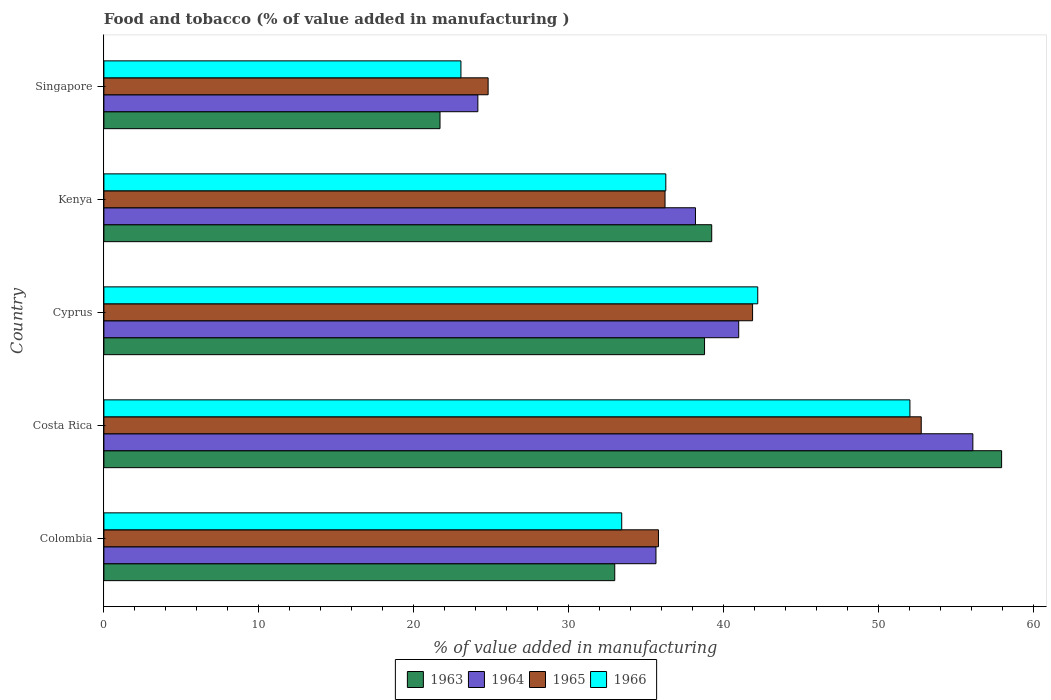How many different coloured bars are there?
Keep it short and to the point. 4. How many groups of bars are there?
Your answer should be compact. 5. How many bars are there on the 2nd tick from the top?
Provide a succinct answer. 4. How many bars are there on the 3rd tick from the bottom?
Give a very brief answer. 4. In how many cases, is the number of bars for a given country not equal to the number of legend labels?
Your answer should be compact. 0. What is the value added in manufacturing food and tobacco in 1965 in Colombia?
Your answer should be compact. 35.78. Across all countries, what is the maximum value added in manufacturing food and tobacco in 1964?
Your answer should be very brief. 56.07. Across all countries, what is the minimum value added in manufacturing food and tobacco in 1965?
Your answer should be compact. 24.79. In which country was the value added in manufacturing food and tobacco in 1965 minimum?
Give a very brief answer. Singapore. What is the total value added in manufacturing food and tobacco in 1964 in the graph?
Make the answer very short. 194.94. What is the difference between the value added in manufacturing food and tobacco in 1966 in Costa Rica and that in Singapore?
Offer a very short reply. 28.97. What is the difference between the value added in manufacturing food and tobacco in 1966 in Cyprus and the value added in manufacturing food and tobacco in 1965 in Kenya?
Provide a short and direct response. 5.98. What is the average value added in manufacturing food and tobacco in 1965 per country?
Ensure brevity in your answer.  38.27. What is the difference between the value added in manufacturing food and tobacco in 1963 and value added in manufacturing food and tobacco in 1965 in Cyprus?
Your response must be concise. -3.1. In how many countries, is the value added in manufacturing food and tobacco in 1964 greater than 50 %?
Provide a short and direct response. 1. What is the ratio of the value added in manufacturing food and tobacco in 1963 in Kenya to that in Singapore?
Provide a short and direct response. 1.81. Is the difference between the value added in manufacturing food and tobacco in 1963 in Kenya and Singapore greater than the difference between the value added in manufacturing food and tobacco in 1965 in Kenya and Singapore?
Make the answer very short. Yes. What is the difference between the highest and the second highest value added in manufacturing food and tobacco in 1964?
Offer a very short reply. 15.11. What is the difference between the highest and the lowest value added in manufacturing food and tobacco in 1964?
Keep it short and to the point. 31.94. Is the sum of the value added in manufacturing food and tobacco in 1963 in Cyprus and Kenya greater than the maximum value added in manufacturing food and tobacco in 1966 across all countries?
Your answer should be compact. Yes. What does the 1st bar from the top in Kenya represents?
Offer a terse response. 1966. What does the 2nd bar from the bottom in Colombia represents?
Offer a terse response. 1964. How many bars are there?
Give a very brief answer. 20. How many countries are there in the graph?
Ensure brevity in your answer.  5. What is the difference between two consecutive major ticks on the X-axis?
Ensure brevity in your answer.  10. Does the graph contain any zero values?
Your answer should be compact. No. Does the graph contain grids?
Your answer should be very brief. No. Where does the legend appear in the graph?
Your answer should be very brief. Bottom center. What is the title of the graph?
Ensure brevity in your answer.  Food and tobacco (% of value added in manufacturing ). What is the label or title of the X-axis?
Give a very brief answer. % of value added in manufacturing. What is the label or title of the Y-axis?
Offer a very short reply. Country. What is the % of value added in manufacturing in 1963 in Colombia?
Offer a terse response. 32.96. What is the % of value added in manufacturing in 1964 in Colombia?
Offer a very short reply. 35.62. What is the % of value added in manufacturing in 1965 in Colombia?
Your answer should be very brief. 35.78. What is the % of value added in manufacturing of 1966 in Colombia?
Your answer should be very brief. 33.41. What is the % of value added in manufacturing in 1963 in Costa Rica?
Offer a terse response. 57.92. What is the % of value added in manufacturing in 1964 in Costa Rica?
Offer a terse response. 56.07. What is the % of value added in manufacturing of 1965 in Costa Rica?
Your response must be concise. 52.73. What is the % of value added in manufacturing of 1966 in Costa Rica?
Provide a short and direct response. 52. What is the % of value added in manufacturing in 1963 in Cyprus?
Make the answer very short. 38.75. What is the % of value added in manufacturing in 1964 in Cyprus?
Make the answer very short. 40.96. What is the % of value added in manufacturing in 1965 in Cyprus?
Offer a very short reply. 41.85. What is the % of value added in manufacturing of 1966 in Cyprus?
Provide a succinct answer. 42.19. What is the % of value added in manufacturing in 1963 in Kenya?
Keep it short and to the point. 39.22. What is the % of value added in manufacturing of 1964 in Kenya?
Give a very brief answer. 38.17. What is the % of value added in manufacturing in 1965 in Kenya?
Offer a very short reply. 36.2. What is the % of value added in manufacturing in 1966 in Kenya?
Make the answer very short. 36.25. What is the % of value added in manufacturing in 1963 in Singapore?
Make the answer very short. 21.69. What is the % of value added in manufacturing in 1964 in Singapore?
Make the answer very short. 24.13. What is the % of value added in manufacturing of 1965 in Singapore?
Ensure brevity in your answer.  24.79. What is the % of value added in manufacturing in 1966 in Singapore?
Offer a very short reply. 23.04. Across all countries, what is the maximum % of value added in manufacturing in 1963?
Your answer should be compact. 57.92. Across all countries, what is the maximum % of value added in manufacturing in 1964?
Give a very brief answer. 56.07. Across all countries, what is the maximum % of value added in manufacturing of 1965?
Your answer should be very brief. 52.73. Across all countries, what is the maximum % of value added in manufacturing of 1966?
Your answer should be compact. 52. Across all countries, what is the minimum % of value added in manufacturing of 1963?
Offer a terse response. 21.69. Across all countries, what is the minimum % of value added in manufacturing of 1964?
Your answer should be very brief. 24.13. Across all countries, what is the minimum % of value added in manufacturing in 1965?
Provide a succinct answer. 24.79. Across all countries, what is the minimum % of value added in manufacturing of 1966?
Offer a terse response. 23.04. What is the total % of value added in manufacturing in 1963 in the graph?
Provide a succinct answer. 190.54. What is the total % of value added in manufacturing in 1964 in the graph?
Give a very brief answer. 194.94. What is the total % of value added in manufacturing in 1965 in the graph?
Make the answer very short. 191.36. What is the total % of value added in manufacturing of 1966 in the graph?
Offer a terse response. 186.89. What is the difference between the % of value added in manufacturing in 1963 in Colombia and that in Costa Rica?
Your answer should be very brief. -24.96. What is the difference between the % of value added in manufacturing of 1964 in Colombia and that in Costa Rica?
Your answer should be very brief. -20.45. What is the difference between the % of value added in manufacturing in 1965 in Colombia and that in Costa Rica?
Your answer should be very brief. -16.95. What is the difference between the % of value added in manufacturing of 1966 in Colombia and that in Costa Rica?
Give a very brief answer. -18.59. What is the difference between the % of value added in manufacturing in 1963 in Colombia and that in Cyprus?
Offer a very short reply. -5.79. What is the difference between the % of value added in manufacturing in 1964 in Colombia and that in Cyprus?
Give a very brief answer. -5.34. What is the difference between the % of value added in manufacturing in 1965 in Colombia and that in Cyprus?
Offer a terse response. -6.07. What is the difference between the % of value added in manufacturing of 1966 in Colombia and that in Cyprus?
Your answer should be very brief. -8.78. What is the difference between the % of value added in manufacturing in 1963 in Colombia and that in Kenya?
Ensure brevity in your answer.  -6.26. What is the difference between the % of value added in manufacturing of 1964 in Colombia and that in Kenya?
Your response must be concise. -2.55. What is the difference between the % of value added in manufacturing in 1965 in Colombia and that in Kenya?
Offer a terse response. -0.42. What is the difference between the % of value added in manufacturing in 1966 in Colombia and that in Kenya?
Your answer should be very brief. -2.84. What is the difference between the % of value added in manufacturing of 1963 in Colombia and that in Singapore?
Ensure brevity in your answer.  11.27. What is the difference between the % of value added in manufacturing in 1964 in Colombia and that in Singapore?
Give a very brief answer. 11.49. What is the difference between the % of value added in manufacturing in 1965 in Colombia and that in Singapore?
Provide a succinct answer. 10.99. What is the difference between the % of value added in manufacturing in 1966 in Colombia and that in Singapore?
Make the answer very short. 10.37. What is the difference between the % of value added in manufacturing of 1963 in Costa Rica and that in Cyprus?
Your response must be concise. 19.17. What is the difference between the % of value added in manufacturing in 1964 in Costa Rica and that in Cyprus?
Your answer should be very brief. 15.11. What is the difference between the % of value added in manufacturing in 1965 in Costa Rica and that in Cyprus?
Ensure brevity in your answer.  10.88. What is the difference between the % of value added in manufacturing of 1966 in Costa Rica and that in Cyprus?
Offer a terse response. 9.82. What is the difference between the % of value added in manufacturing of 1963 in Costa Rica and that in Kenya?
Ensure brevity in your answer.  18.7. What is the difference between the % of value added in manufacturing in 1964 in Costa Rica and that in Kenya?
Keep it short and to the point. 17.9. What is the difference between the % of value added in manufacturing of 1965 in Costa Rica and that in Kenya?
Your response must be concise. 16.53. What is the difference between the % of value added in manufacturing in 1966 in Costa Rica and that in Kenya?
Provide a succinct answer. 15.75. What is the difference between the % of value added in manufacturing of 1963 in Costa Rica and that in Singapore?
Provide a short and direct response. 36.23. What is the difference between the % of value added in manufacturing of 1964 in Costa Rica and that in Singapore?
Ensure brevity in your answer.  31.94. What is the difference between the % of value added in manufacturing in 1965 in Costa Rica and that in Singapore?
Keep it short and to the point. 27.94. What is the difference between the % of value added in manufacturing in 1966 in Costa Rica and that in Singapore?
Your answer should be compact. 28.97. What is the difference between the % of value added in manufacturing in 1963 in Cyprus and that in Kenya?
Offer a terse response. -0.46. What is the difference between the % of value added in manufacturing of 1964 in Cyprus and that in Kenya?
Keep it short and to the point. 2.79. What is the difference between the % of value added in manufacturing of 1965 in Cyprus and that in Kenya?
Ensure brevity in your answer.  5.65. What is the difference between the % of value added in manufacturing in 1966 in Cyprus and that in Kenya?
Your response must be concise. 5.93. What is the difference between the % of value added in manufacturing in 1963 in Cyprus and that in Singapore?
Give a very brief answer. 17.07. What is the difference between the % of value added in manufacturing in 1964 in Cyprus and that in Singapore?
Give a very brief answer. 16.83. What is the difference between the % of value added in manufacturing of 1965 in Cyprus and that in Singapore?
Make the answer very short. 17.06. What is the difference between the % of value added in manufacturing of 1966 in Cyprus and that in Singapore?
Keep it short and to the point. 19.15. What is the difference between the % of value added in manufacturing in 1963 in Kenya and that in Singapore?
Provide a succinct answer. 17.53. What is the difference between the % of value added in manufacturing in 1964 in Kenya and that in Singapore?
Your answer should be very brief. 14.04. What is the difference between the % of value added in manufacturing of 1965 in Kenya and that in Singapore?
Give a very brief answer. 11.41. What is the difference between the % of value added in manufacturing in 1966 in Kenya and that in Singapore?
Make the answer very short. 13.22. What is the difference between the % of value added in manufacturing of 1963 in Colombia and the % of value added in manufacturing of 1964 in Costa Rica?
Give a very brief answer. -23.11. What is the difference between the % of value added in manufacturing of 1963 in Colombia and the % of value added in manufacturing of 1965 in Costa Rica?
Give a very brief answer. -19.77. What is the difference between the % of value added in manufacturing in 1963 in Colombia and the % of value added in manufacturing in 1966 in Costa Rica?
Offer a very short reply. -19.04. What is the difference between the % of value added in manufacturing in 1964 in Colombia and the % of value added in manufacturing in 1965 in Costa Rica?
Provide a succinct answer. -17.11. What is the difference between the % of value added in manufacturing of 1964 in Colombia and the % of value added in manufacturing of 1966 in Costa Rica?
Your answer should be compact. -16.38. What is the difference between the % of value added in manufacturing in 1965 in Colombia and the % of value added in manufacturing in 1966 in Costa Rica?
Provide a short and direct response. -16.22. What is the difference between the % of value added in manufacturing in 1963 in Colombia and the % of value added in manufacturing in 1964 in Cyprus?
Offer a terse response. -8. What is the difference between the % of value added in manufacturing of 1963 in Colombia and the % of value added in manufacturing of 1965 in Cyprus?
Provide a short and direct response. -8.89. What is the difference between the % of value added in manufacturing of 1963 in Colombia and the % of value added in manufacturing of 1966 in Cyprus?
Provide a short and direct response. -9.23. What is the difference between the % of value added in manufacturing in 1964 in Colombia and the % of value added in manufacturing in 1965 in Cyprus?
Keep it short and to the point. -6.23. What is the difference between the % of value added in manufacturing of 1964 in Colombia and the % of value added in manufacturing of 1966 in Cyprus?
Provide a short and direct response. -6.57. What is the difference between the % of value added in manufacturing in 1965 in Colombia and the % of value added in manufacturing in 1966 in Cyprus?
Offer a terse response. -6.41. What is the difference between the % of value added in manufacturing of 1963 in Colombia and the % of value added in manufacturing of 1964 in Kenya?
Give a very brief answer. -5.21. What is the difference between the % of value added in manufacturing of 1963 in Colombia and the % of value added in manufacturing of 1965 in Kenya?
Offer a terse response. -3.24. What is the difference between the % of value added in manufacturing of 1963 in Colombia and the % of value added in manufacturing of 1966 in Kenya?
Your answer should be compact. -3.29. What is the difference between the % of value added in manufacturing in 1964 in Colombia and the % of value added in manufacturing in 1965 in Kenya?
Provide a short and direct response. -0.58. What is the difference between the % of value added in manufacturing in 1964 in Colombia and the % of value added in manufacturing in 1966 in Kenya?
Keep it short and to the point. -0.63. What is the difference between the % of value added in manufacturing in 1965 in Colombia and the % of value added in manufacturing in 1966 in Kenya?
Your response must be concise. -0.47. What is the difference between the % of value added in manufacturing of 1963 in Colombia and the % of value added in manufacturing of 1964 in Singapore?
Your answer should be very brief. 8.83. What is the difference between the % of value added in manufacturing of 1963 in Colombia and the % of value added in manufacturing of 1965 in Singapore?
Offer a very short reply. 8.17. What is the difference between the % of value added in manufacturing of 1963 in Colombia and the % of value added in manufacturing of 1966 in Singapore?
Offer a very short reply. 9.92. What is the difference between the % of value added in manufacturing of 1964 in Colombia and the % of value added in manufacturing of 1965 in Singapore?
Provide a short and direct response. 10.83. What is the difference between the % of value added in manufacturing of 1964 in Colombia and the % of value added in manufacturing of 1966 in Singapore?
Offer a terse response. 12.58. What is the difference between the % of value added in manufacturing in 1965 in Colombia and the % of value added in manufacturing in 1966 in Singapore?
Your answer should be compact. 12.74. What is the difference between the % of value added in manufacturing of 1963 in Costa Rica and the % of value added in manufacturing of 1964 in Cyprus?
Give a very brief answer. 16.96. What is the difference between the % of value added in manufacturing in 1963 in Costa Rica and the % of value added in manufacturing in 1965 in Cyprus?
Make the answer very short. 16.07. What is the difference between the % of value added in manufacturing in 1963 in Costa Rica and the % of value added in manufacturing in 1966 in Cyprus?
Make the answer very short. 15.73. What is the difference between the % of value added in manufacturing in 1964 in Costa Rica and the % of value added in manufacturing in 1965 in Cyprus?
Your answer should be compact. 14.21. What is the difference between the % of value added in manufacturing of 1964 in Costa Rica and the % of value added in manufacturing of 1966 in Cyprus?
Give a very brief answer. 13.88. What is the difference between the % of value added in manufacturing of 1965 in Costa Rica and the % of value added in manufacturing of 1966 in Cyprus?
Make the answer very short. 10.55. What is the difference between the % of value added in manufacturing of 1963 in Costa Rica and the % of value added in manufacturing of 1964 in Kenya?
Your response must be concise. 19.75. What is the difference between the % of value added in manufacturing in 1963 in Costa Rica and the % of value added in manufacturing in 1965 in Kenya?
Offer a terse response. 21.72. What is the difference between the % of value added in manufacturing of 1963 in Costa Rica and the % of value added in manufacturing of 1966 in Kenya?
Provide a short and direct response. 21.67. What is the difference between the % of value added in manufacturing of 1964 in Costa Rica and the % of value added in manufacturing of 1965 in Kenya?
Offer a terse response. 19.86. What is the difference between the % of value added in manufacturing in 1964 in Costa Rica and the % of value added in manufacturing in 1966 in Kenya?
Ensure brevity in your answer.  19.81. What is the difference between the % of value added in manufacturing of 1965 in Costa Rica and the % of value added in manufacturing of 1966 in Kenya?
Provide a succinct answer. 16.48. What is the difference between the % of value added in manufacturing in 1963 in Costa Rica and the % of value added in manufacturing in 1964 in Singapore?
Your answer should be very brief. 33.79. What is the difference between the % of value added in manufacturing of 1963 in Costa Rica and the % of value added in manufacturing of 1965 in Singapore?
Ensure brevity in your answer.  33.13. What is the difference between the % of value added in manufacturing in 1963 in Costa Rica and the % of value added in manufacturing in 1966 in Singapore?
Give a very brief answer. 34.88. What is the difference between the % of value added in manufacturing of 1964 in Costa Rica and the % of value added in manufacturing of 1965 in Singapore?
Keep it short and to the point. 31.28. What is the difference between the % of value added in manufacturing in 1964 in Costa Rica and the % of value added in manufacturing in 1966 in Singapore?
Your answer should be compact. 33.03. What is the difference between the % of value added in manufacturing in 1965 in Costa Rica and the % of value added in manufacturing in 1966 in Singapore?
Provide a short and direct response. 29.7. What is the difference between the % of value added in manufacturing in 1963 in Cyprus and the % of value added in manufacturing in 1964 in Kenya?
Your answer should be compact. 0.59. What is the difference between the % of value added in manufacturing in 1963 in Cyprus and the % of value added in manufacturing in 1965 in Kenya?
Give a very brief answer. 2.55. What is the difference between the % of value added in manufacturing in 1963 in Cyprus and the % of value added in manufacturing in 1966 in Kenya?
Make the answer very short. 2.5. What is the difference between the % of value added in manufacturing of 1964 in Cyprus and the % of value added in manufacturing of 1965 in Kenya?
Keep it short and to the point. 4.75. What is the difference between the % of value added in manufacturing in 1964 in Cyprus and the % of value added in manufacturing in 1966 in Kenya?
Offer a very short reply. 4.7. What is the difference between the % of value added in manufacturing in 1965 in Cyprus and the % of value added in manufacturing in 1966 in Kenya?
Offer a very short reply. 5.6. What is the difference between the % of value added in manufacturing in 1963 in Cyprus and the % of value added in manufacturing in 1964 in Singapore?
Provide a short and direct response. 14.63. What is the difference between the % of value added in manufacturing in 1963 in Cyprus and the % of value added in manufacturing in 1965 in Singapore?
Offer a very short reply. 13.96. What is the difference between the % of value added in manufacturing in 1963 in Cyprus and the % of value added in manufacturing in 1966 in Singapore?
Your response must be concise. 15.72. What is the difference between the % of value added in manufacturing of 1964 in Cyprus and the % of value added in manufacturing of 1965 in Singapore?
Give a very brief answer. 16.17. What is the difference between the % of value added in manufacturing of 1964 in Cyprus and the % of value added in manufacturing of 1966 in Singapore?
Offer a terse response. 17.92. What is the difference between the % of value added in manufacturing in 1965 in Cyprus and the % of value added in manufacturing in 1966 in Singapore?
Make the answer very short. 18.82. What is the difference between the % of value added in manufacturing of 1963 in Kenya and the % of value added in manufacturing of 1964 in Singapore?
Keep it short and to the point. 15.09. What is the difference between the % of value added in manufacturing in 1963 in Kenya and the % of value added in manufacturing in 1965 in Singapore?
Give a very brief answer. 14.43. What is the difference between the % of value added in manufacturing of 1963 in Kenya and the % of value added in manufacturing of 1966 in Singapore?
Offer a very short reply. 16.18. What is the difference between the % of value added in manufacturing in 1964 in Kenya and the % of value added in manufacturing in 1965 in Singapore?
Your response must be concise. 13.38. What is the difference between the % of value added in manufacturing of 1964 in Kenya and the % of value added in manufacturing of 1966 in Singapore?
Offer a terse response. 15.13. What is the difference between the % of value added in manufacturing of 1965 in Kenya and the % of value added in manufacturing of 1966 in Singapore?
Make the answer very short. 13.17. What is the average % of value added in manufacturing in 1963 per country?
Provide a short and direct response. 38.11. What is the average % of value added in manufacturing in 1964 per country?
Your answer should be very brief. 38.99. What is the average % of value added in manufacturing in 1965 per country?
Offer a terse response. 38.27. What is the average % of value added in manufacturing in 1966 per country?
Offer a terse response. 37.38. What is the difference between the % of value added in manufacturing in 1963 and % of value added in manufacturing in 1964 in Colombia?
Ensure brevity in your answer.  -2.66. What is the difference between the % of value added in manufacturing in 1963 and % of value added in manufacturing in 1965 in Colombia?
Ensure brevity in your answer.  -2.82. What is the difference between the % of value added in manufacturing of 1963 and % of value added in manufacturing of 1966 in Colombia?
Provide a short and direct response. -0.45. What is the difference between the % of value added in manufacturing in 1964 and % of value added in manufacturing in 1965 in Colombia?
Keep it short and to the point. -0.16. What is the difference between the % of value added in manufacturing of 1964 and % of value added in manufacturing of 1966 in Colombia?
Offer a very short reply. 2.21. What is the difference between the % of value added in manufacturing in 1965 and % of value added in manufacturing in 1966 in Colombia?
Offer a terse response. 2.37. What is the difference between the % of value added in manufacturing of 1963 and % of value added in manufacturing of 1964 in Costa Rica?
Make the answer very short. 1.85. What is the difference between the % of value added in manufacturing of 1963 and % of value added in manufacturing of 1965 in Costa Rica?
Provide a succinct answer. 5.19. What is the difference between the % of value added in manufacturing of 1963 and % of value added in manufacturing of 1966 in Costa Rica?
Your answer should be very brief. 5.92. What is the difference between the % of value added in manufacturing of 1964 and % of value added in manufacturing of 1965 in Costa Rica?
Make the answer very short. 3.33. What is the difference between the % of value added in manufacturing in 1964 and % of value added in manufacturing in 1966 in Costa Rica?
Offer a terse response. 4.06. What is the difference between the % of value added in manufacturing in 1965 and % of value added in manufacturing in 1966 in Costa Rica?
Offer a very short reply. 0.73. What is the difference between the % of value added in manufacturing of 1963 and % of value added in manufacturing of 1964 in Cyprus?
Provide a short and direct response. -2.2. What is the difference between the % of value added in manufacturing in 1963 and % of value added in manufacturing in 1965 in Cyprus?
Your answer should be compact. -3.1. What is the difference between the % of value added in manufacturing of 1963 and % of value added in manufacturing of 1966 in Cyprus?
Provide a short and direct response. -3.43. What is the difference between the % of value added in manufacturing of 1964 and % of value added in manufacturing of 1965 in Cyprus?
Your response must be concise. -0.9. What is the difference between the % of value added in manufacturing in 1964 and % of value added in manufacturing in 1966 in Cyprus?
Give a very brief answer. -1.23. What is the difference between the % of value added in manufacturing in 1963 and % of value added in manufacturing in 1964 in Kenya?
Your answer should be very brief. 1.05. What is the difference between the % of value added in manufacturing in 1963 and % of value added in manufacturing in 1965 in Kenya?
Your answer should be very brief. 3.01. What is the difference between the % of value added in manufacturing in 1963 and % of value added in manufacturing in 1966 in Kenya?
Your answer should be compact. 2.96. What is the difference between the % of value added in manufacturing in 1964 and % of value added in manufacturing in 1965 in Kenya?
Give a very brief answer. 1.96. What is the difference between the % of value added in manufacturing in 1964 and % of value added in manufacturing in 1966 in Kenya?
Make the answer very short. 1.91. What is the difference between the % of value added in manufacturing in 1965 and % of value added in manufacturing in 1966 in Kenya?
Your answer should be very brief. -0.05. What is the difference between the % of value added in manufacturing in 1963 and % of value added in manufacturing in 1964 in Singapore?
Provide a succinct answer. -2.44. What is the difference between the % of value added in manufacturing of 1963 and % of value added in manufacturing of 1965 in Singapore?
Keep it short and to the point. -3.1. What is the difference between the % of value added in manufacturing in 1963 and % of value added in manufacturing in 1966 in Singapore?
Provide a short and direct response. -1.35. What is the difference between the % of value added in manufacturing in 1964 and % of value added in manufacturing in 1965 in Singapore?
Ensure brevity in your answer.  -0.66. What is the difference between the % of value added in manufacturing of 1964 and % of value added in manufacturing of 1966 in Singapore?
Your response must be concise. 1.09. What is the difference between the % of value added in manufacturing of 1965 and % of value added in manufacturing of 1966 in Singapore?
Keep it short and to the point. 1.75. What is the ratio of the % of value added in manufacturing of 1963 in Colombia to that in Costa Rica?
Give a very brief answer. 0.57. What is the ratio of the % of value added in manufacturing in 1964 in Colombia to that in Costa Rica?
Provide a succinct answer. 0.64. What is the ratio of the % of value added in manufacturing in 1965 in Colombia to that in Costa Rica?
Ensure brevity in your answer.  0.68. What is the ratio of the % of value added in manufacturing of 1966 in Colombia to that in Costa Rica?
Your answer should be compact. 0.64. What is the ratio of the % of value added in manufacturing in 1963 in Colombia to that in Cyprus?
Give a very brief answer. 0.85. What is the ratio of the % of value added in manufacturing in 1964 in Colombia to that in Cyprus?
Your answer should be compact. 0.87. What is the ratio of the % of value added in manufacturing in 1965 in Colombia to that in Cyprus?
Ensure brevity in your answer.  0.85. What is the ratio of the % of value added in manufacturing of 1966 in Colombia to that in Cyprus?
Give a very brief answer. 0.79. What is the ratio of the % of value added in manufacturing of 1963 in Colombia to that in Kenya?
Keep it short and to the point. 0.84. What is the ratio of the % of value added in manufacturing in 1964 in Colombia to that in Kenya?
Give a very brief answer. 0.93. What is the ratio of the % of value added in manufacturing of 1965 in Colombia to that in Kenya?
Make the answer very short. 0.99. What is the ratio of the % of value added in manufacturing of 1966 in Colombia to that in Kenya?
Make the answer very short. 0.92. What is the ratio of the % of value added in manufacturing of 1963 in Colombia to that in Singapore?
Your answer should be compact. 1.52. What is the ratio of the % of value added in manufacturing in 1964 in Colombia to that in Singapore?
Your answer should be very brief. 1.48. What is the ratio of the % of value added in manufacturing of 1965 in Colombia to that in Singapore?
Offer a very short reply. 1.44. What is the ratio of the % of value added in manufacturing of 1966 in Colombia to that in Singapore?
Give a very brief answer. 1.45. What is the ratio of the % of value added in manufacturing of 1963 in Costa Rica to that in Cyprus?
Your answer should be compact. 1.49. What is the ratio of the % of value added in manufacturing in 1964 in Costa Rica to that in Cyprus?
Make the answer very short. 1.37. What is the ratio of the % of value added in manufacturing in 1965 in Costa Rica to that in Cyprus?
Offer a very short reply. 1.26. What is the ratio of the % of value added in manufacturing of 1966 in Costa Rica to that in Cyprus?
Make the answer very short. 1.23. What is the ratio of the % of value added in manufacturing in 1963 in Costa Rica to that in Kenya?
Give a very brief answer. 1.48. What is the ratio of the % of value added in manufacturing of 1964 in Costa Rica to that in Kenya?
Offer a very short reply. 1.47. What is the ratio of the % of value added in manufacturing in 1965 in Costa Rica to that in Kenya?
Provide a short and direct response. 1.46. What is the ratio of the % of value added in manufacturing of 1966 in Costa Rica to that in Kenya?
Offer a very short reply. 1.43. What is the ratio of the % of value added in manufacturing of 1963 in Costa Rica to that in Singapore?
Give a very brief answer. 2.67. What is the ratio of the % of value added in manufacturing in 1964 in Costa Rica to that in Singapore?
Provide a short and direct response. 2.32. What is the ratio of the % of value added in manufacturing in 1965 in Costa Rica to that in Singapore?
Keep it short and to the point. 2.13. What is the ratio of the % of value added in manufacturing in 1966 in Costa Rica to that in Singapore?
Give a very brief answer. 2.26. What is the ratio of the % of value added in manufacturing in 1964 in Cyprus to that in Kenya?
Offer a very short reply. 1.07. What is the ratio of the % of value added in manufacturing of 1965 in Cyprus to that in Kenya?
Your response must be concise. 1.16. What is the ratio of the % of value added in manufacturing in 1966 in Cyprus to that in Kenya?
Make the answer very short. 1.16. What is the ratio of the % of value added in manufacturing in 1963 in Cyprus to that in Singapore?
Keep it short and to the point. 1.79. What is the ratio of the % of value added in manufacturing of 1964 in Cyprus to that in Singapore?
Your answer should be very brief. 1.7. What is the ratio of the % of value added in manufacturing in 1965 in Cyprus to that in Singapore?
Give a very brief answer. 1.69. What is the ratio of the % of value added in manufacturing of 1966 in Cyprus to that in Singapore?
Offer a terse response. 1.83. What is the ratio of the % of value added in manufacturing of 1963 in Kenya to that in Singapore?
Your answer should be compact. 1.81. What is the ratio of the % of value added in manufacturing in 1964 in Kenya to that in Singapore?
Keep it short and to the point. 1.58. What is the ratio of the % of value added in manufacturing of 1965 in Kenya to that in Singapore?
Offer a terse response. 1.46. What is the ratio of the % of value added in manufacturing in 1966 in Kenya to that in Singapore?
Your response must be concise. 1.57. What is the difference between the highest and the second highest % of value added in manufacturing in 1963?
Provide a succinct answer. 18.7. What is the difference between the highest and the second highest % of value added in manufacturing in 1964?
Ensure brevity in your answer.  15.11. What is the difference between the highest and the second highest % of value added in manufacturing of 1965?
Your response must be concise. 10.88. What is the difference between the highest and the second highest % of value added in manufacturing of 1966?
Your answer should be very brief. 9.82. What is the difference between the highest and the lowest % of value added in manufacturing of 1963?
Make the answer very short. 36.23. What is the difference between the highest and the lowest % of value added in manufacturing in 1964?
Give a very brief answer. 31.94. What is the difference between the highest and the lowest % of value added in manufacturing of 1965?
Offer a very short reply. 27.94. What is the difference between the highest and the lowest % of value added in manufacturing in 1966?
Your response must be concise. 28.97. 